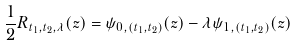<formula> <loc_0><loc_0><loc_500><loc_500>\frac { 1 } { 2 } R _ { t _ { 1 } , t _ { 2 } , \lambda } ( z ) = \psi _ { 0 , ( t _ { 1 } , t _ { 2 } ) } ( z ) - \lambda \psi _ { 1 , ( t _ { 1 } , t _ { 2 } ) } ( z )</formula> 